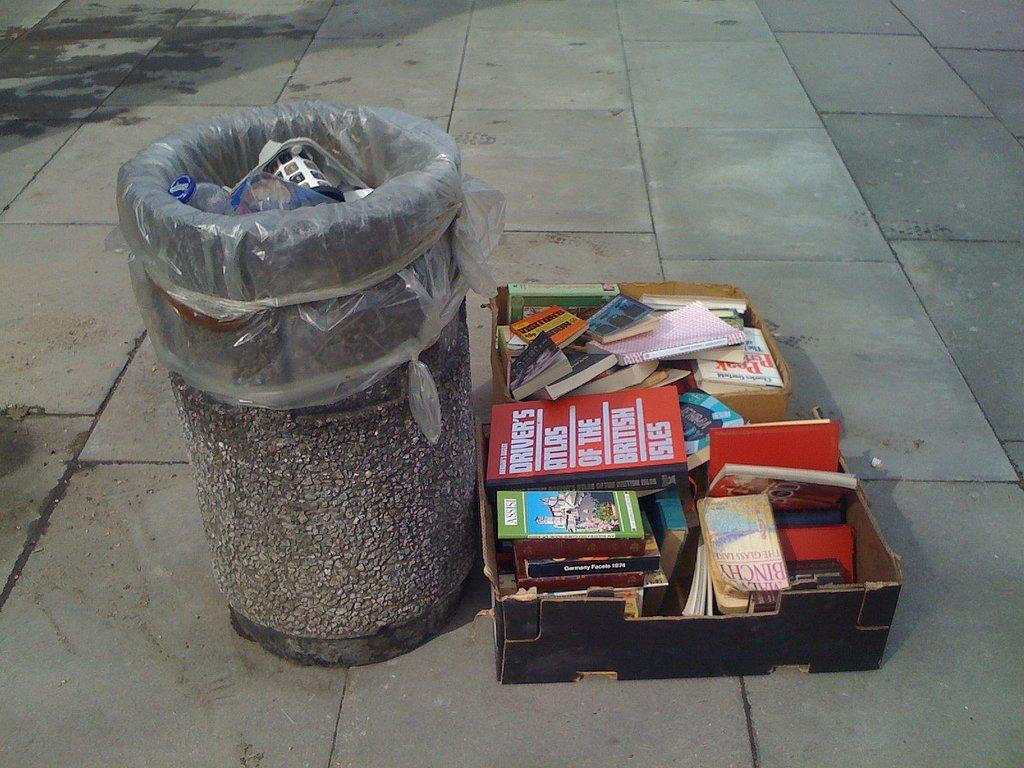<image>
Relay a brief, clear account of the picture shown. A trashcan has a box of books next to it and one of the books says Assisi. 